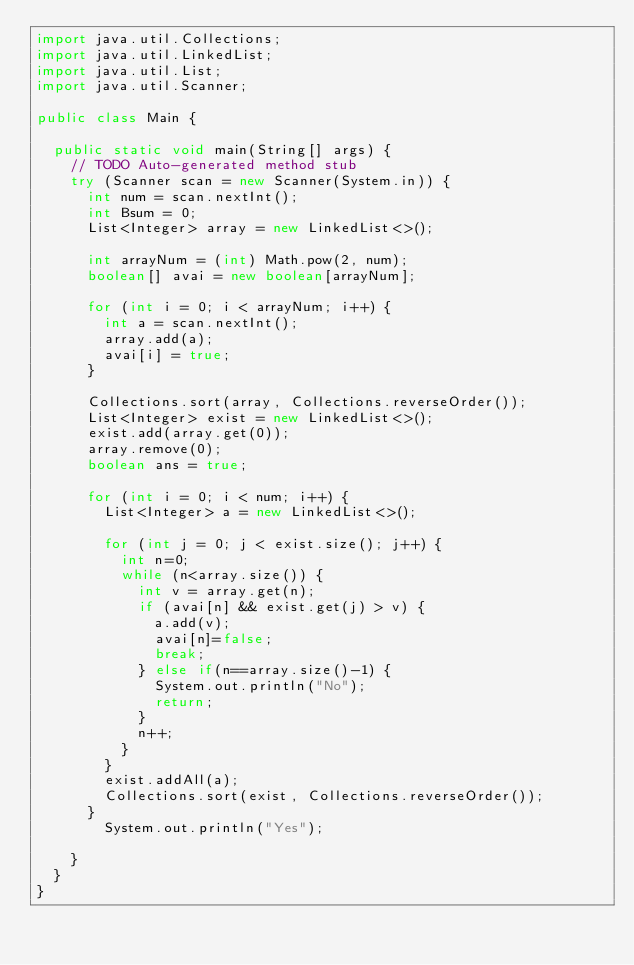<code> <loc_0><loc_0><loc_500><loc_500><_Java_>import java.util.Collections;
import java.util.LinkedList;
import java.util.List;
import java.util.Scanner;

public class Main {

	public static void main(String[] args) {
		// TODO Auto-generated method stub
		try (Scanner scan = new Scanner(System.in)) {
			int num = scan.nextInt();
			int Bsum = 0;
			List<Integer> array = new LinkedList<>();

			int arrayNum = (int) Math.pow(2, num);
			boolean[] avai = new boolean[arrayNum];
			
			for (int i = 0; i < arrayNum; i++) {
				int a = scan.nextInt();
				array.add(a);
				avai[i] = true;
			}

			Collections.sort(array, Collections.reverseOrder());
			List<Integer> exist = new LinkedList<>();
			exist.add(array.get(0));
			array.remove(0);
			boolean ans = true;

			for (int i = 0; i < num; i++) {
				List<Integer> a = new LinkedList<>();

				for (int j = 0; j < exist.size(); j++) {
					int n=0;
					while (n<array.size()) {
						int v = array.get(n);
						if (avai[n] && exist.get(j) > v) {
							a.add(v);
							avai[n]=false;
							break;
						} else if(n==array.size()-1) {
							System.out.println("No");
							return;
						}
						n++;
					}
				}
				exist.addAll(a);
				Collections.sort(exist, Collections.reverseOrder());
			}
				System.out.println("Yes");

		}
	}
}</code> 